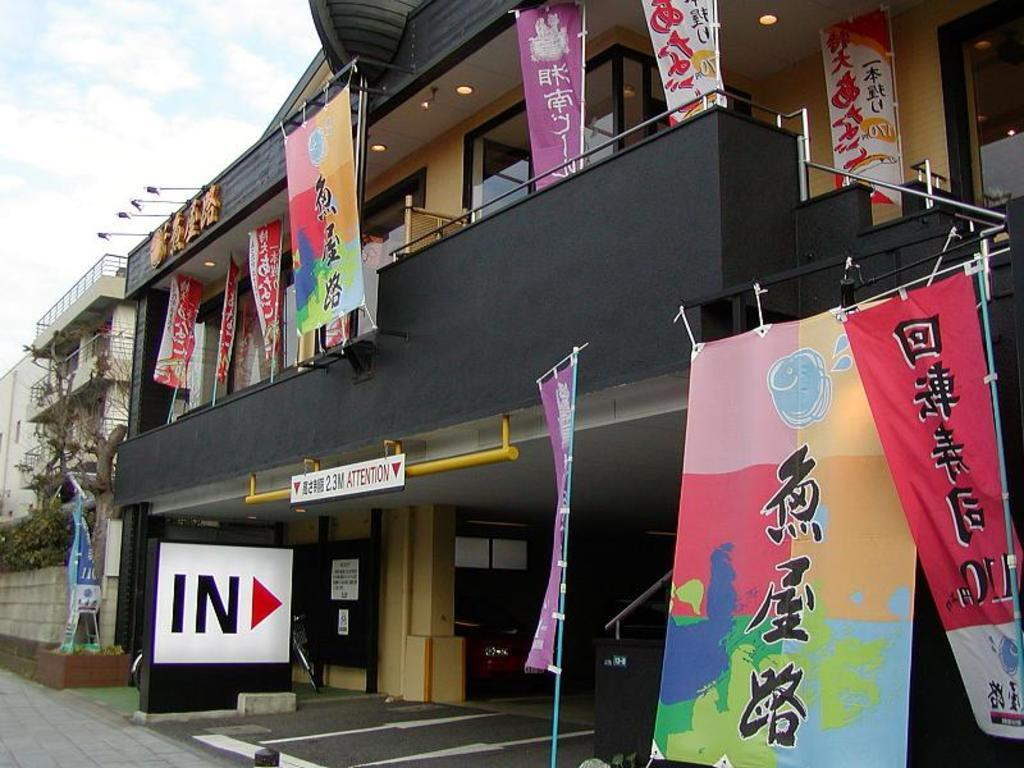What type of structures can be seen in the image? There are buildings in the image. What is hanging in front of the buildings? Banners are present in front of the buildings. What part of the natural environment is visible in the image? The sky is visible in the top left corner of the image. What can be observed in the sky? Clouds are present in the sky. What type of gold ray can be seen emanating from the buildings in the image? There is no gold ray present in the image; it only features buildings, banners, and clouds in the sky. 